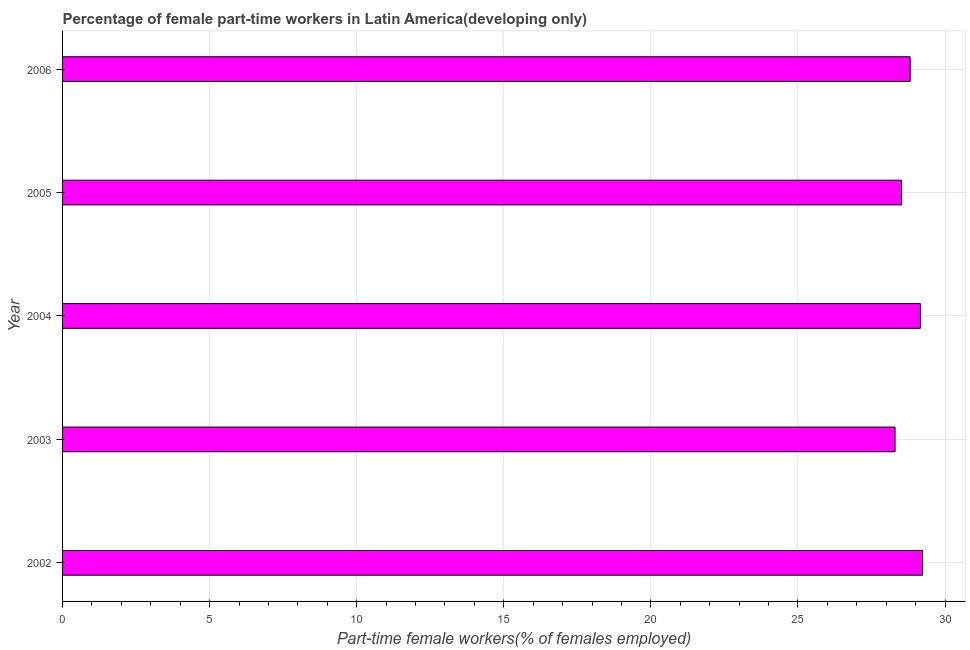What is the title of the graph?
Ensure brevity in your answer.  Percentage of female part-time workers in Latin America(developing only). What is the label or title of the X-axis?
Offer a very short reply. Part-time female workers(% of females employed). What is the label or title of the Y-axis?
Your answer should be very brief. Year. What is the percentage of part-time female workers in 2005?
Give a very brief answer. 28.52. Across all years, what is the maximum percentage of part-time female workers?
Provide a short and direct response. 29.23. Across all years, what is the minimum percentage of part-time female workers?
Ensure brevity in your answer.  28.3. In which year was the percentage of part-time female workers maximum?
Keep it short and to the point. 2002. What is the sum of the percentage of part-time female workers?
Your answer should be compact. 144.03. What is the difference between the percentage of part-time female workers in 2004 and 2005?
Your answer should be compact. 0.64. What is the average percentage of part-time female workers per year?
Your answer should be very brief. 28.81. What is the median percentage of part-time female workers?
Give a very brief answer. 28.81. What is the ratio of the percentage of part-time female workers in 2002 to that in 2006?
Your response must be concise. 1.01. What is the difference between the highest and the second highest percentage of part-time female workers?
Give a very brief answer. 0.07. Is the sum of the percentage of part-time female workers in 2002 and 2004 greater than the maximum percentage of part-time female workers across all years?
Provide a short and direct response. Yes. How many years are there in the graph?
Your answer should be compact. 5. What is the Part-time female workers(% of females employed) in 2002?
Your answer should be compact. 29.23. What is the Part-time female workers(% of females employed) in 2003?
Keep it short and to the point. 28.3. What is the Part-time female workers(% of females employed) of 2004?
Provide a short and direct response. 29.16. What is the Part-time female workers(% of females employed) of 2005?
Offer a terse response. 28.52. What is the Part-time female workers(% of females employed) of 2006?
Keep it short and to the point. 28.81. What is the difference between the Part-time female workers(% of females employed) in 2002 and 2003?
Provide a short and direct response. 0.93. What is the difference between the Part-time female workers(% of females employed) in 2002 and 2004?
Keep it short and to the point. 0.07. What is the difference between the Part-time female workers(% of females employed) in 2002 and 2005?
Provide a succinct answer. 0.71. What is the difference between the Part-time female workers(% of females employed) in 2002 and 2006?
Ensure brevity in your answer.  0.42. What is the difference between the Part-time female workers(% of females employed) in 2003 and 2004?
Ensure brevity in your answer.  -0.86. What is the difference between the Part-time female workers(% of females employed) in 2003 and 2005?
Keep it short and to the point. -0.22. What is the difference between the Part-time female workers(% of females employed) in 2003 and 2006?
Offer a terse response. -0.51. What is the difference between the Part-time female workers(% of females employed) in 2004 and 2005?
Your response must be concise. 0.64. What is the difference between the Part-time female workers(% of females employed) in 2004 and 2006?
Offer a terse response. 0.35. What is the difference between the Part-time female workers(% of females employed) in 2005 and 2006?
Provide a succinct answer. -0.29. What is the ratio of the Part-time female workers(% of females employed) in 2002 to that in 2003?
Your response must be concise. 1.03. What is the ratio of the Part-time female workers(% of females employed) in 2002 to that in 2005?
Give a very brief answer. 1.02. What is the ratio of the Part-time female workers(% of females employed) in 2002 to that in 2006?
Your answer should be compact. 1.01. What is the ratio of the Part-time female workers(% of females employed) in 2003 to that in 2006?
Provide a short and direct response. 0.98. What is the ratio of the Part-time female workers(% of females employed) in 2004 to that in 2006?
Make the answer very short. 1.01. 